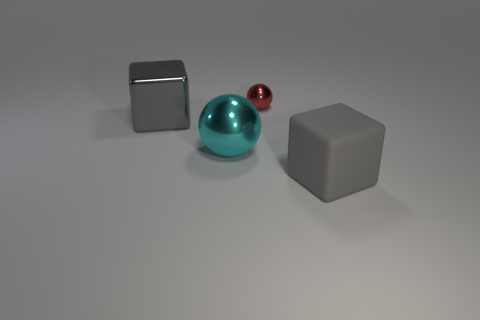Add 2 large gray objects. How many objects exist? 6 Add 4 metallic cubes. How many metallic cubes exist? 5 Subtract 0 brown blocks. How many objects are left? 4 Subtract all purple matte objects. Subtract all balls. How many objects are left? 2 Add 2 large shiny things. How many large shiny things are left? 4 